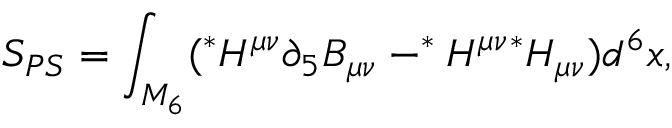<formula> <loc_0><loc_0><loc_500><loc_500>S _ { P S } = \int _ { M _ { 6 } } ( ^ { * } H ^ { \mu \nu } \partial _ { 5 } B _ { \mu \nu } - ^ { * } H ^ { \mu \nu ^ { * } H _ { \mu \nu } ) d ^ { 6 } x ,</formula> 